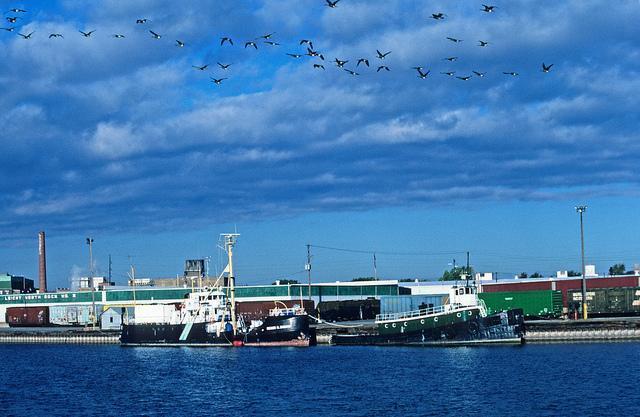How many boats are there?
Give a very brief answer. 3. How many chairs can you see?
Give a very brief answer. 0. 